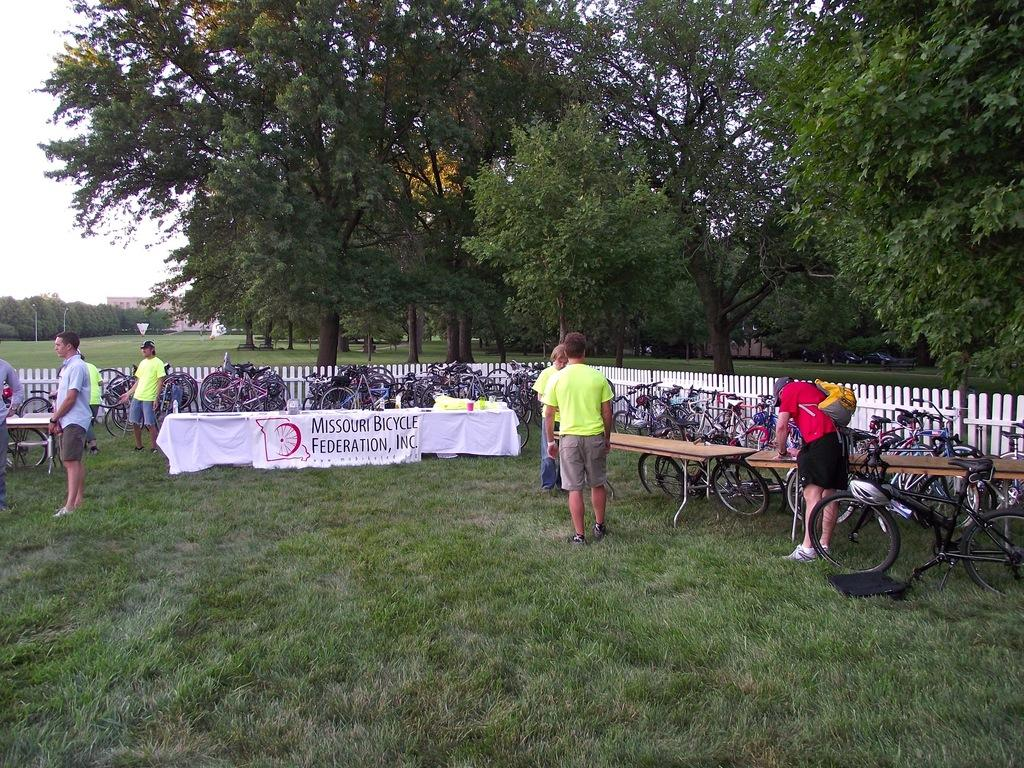How many people can be seen in the image? There are people in the image, but the exact number is not specified. What type of furniture is present in the image? There are tables in the image. What mode of transportation can be seen in the image? There are bicycles in the image. Where are the objects located in the image? The objects are on the grass. What can be seen in the background of the image? There is a fence, trees, and a building in the background of the image. What type of coach can be seen in the image? There is no coach present in the image. What thrilling activity is taking place in the image? The image does not depict any specific thrilling activity. 